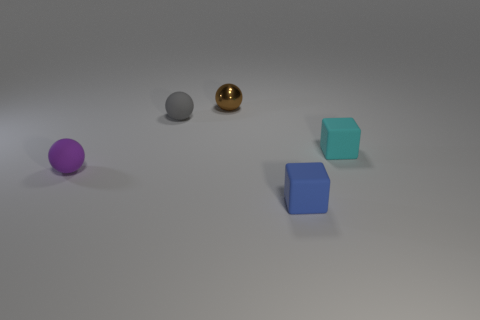Can you tell me what the colors of the objects are from left to right? From left to right, the objects have the following colors: purple, gray, gold, cyan, and blue. 